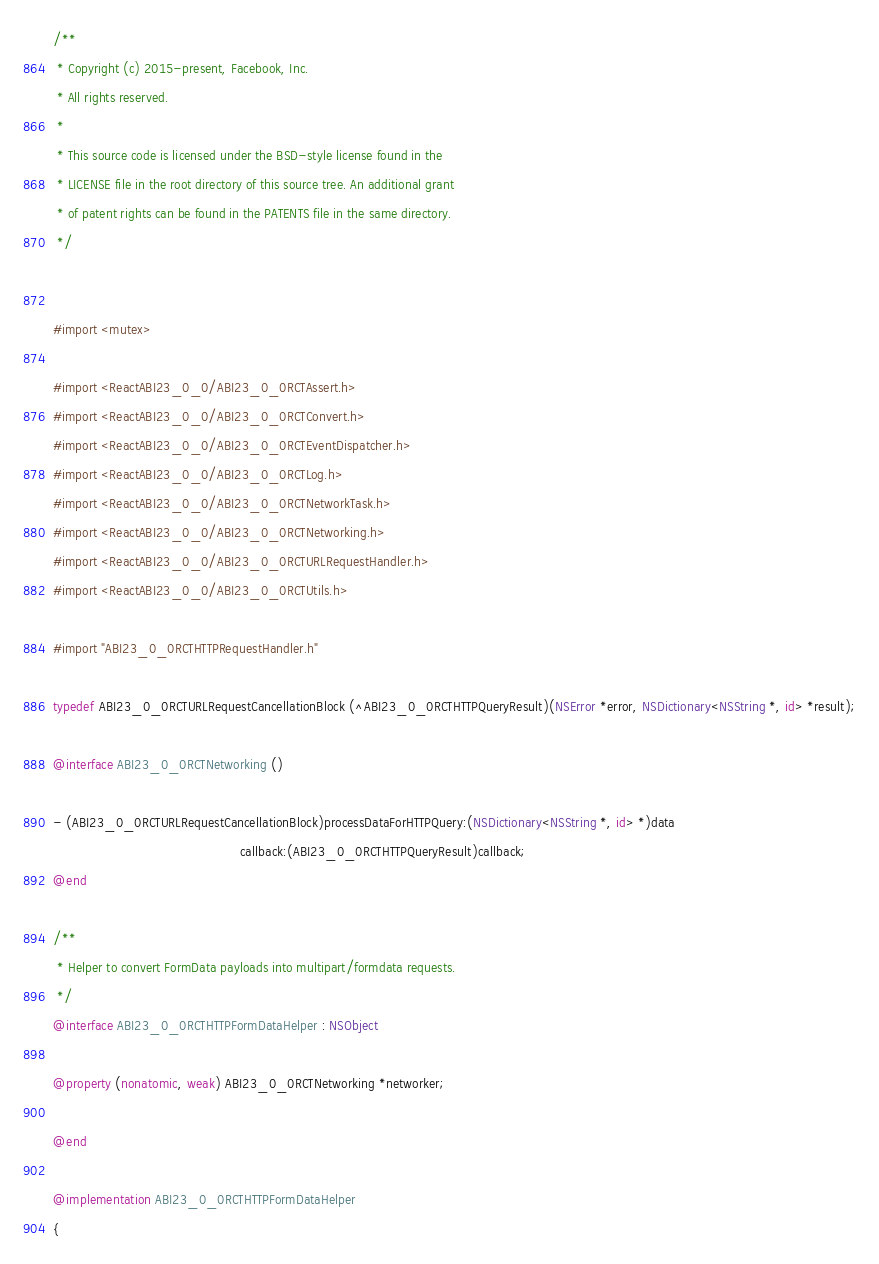Convert code to text. <code><loc_0><loc_0><loc_500><loc_500><_ObjectiveC_>/**
 * Copyright (c) 2015-present, Facebook, Inc.
 * All rights reserved.
 *
 * This source code is licensed under the BSD-style license found in the
 * LICENSE file in the root directory of this source tree. An additional grant
 * of patent rights can be found in the PATENTS file in the same directory.
 */


#import <mutex>

#import <ReactABI23_0_0/ABI23_0_0RCTAssert.h>
#import <ReactABI23_0_0/ABI23_0_0RCTConvert.h>
#import <ReactABI23_0_0/ABI23_0_0RCTEventDispatcher.h>
#import <ReactABI23_0_0/ABI23_0_0RCTLog.h>
#import <ReactABI23_0_0/ABI23_0_0RCTNetworkTask.h>
#import <ReactABI23_0_0/ABI23_0_0RCTNetworking.h>
#import <ReactABI23_0_0/ABI23_0_0RCTURLRequestHandler.h>
#import <ReactABI23_0_0/ABI23_0_0RCTUtils.h>

#import "ABI23_0_0RCTHTTPRequestHandler.h"

typedef ABI23_0_0RCTURLRequestCancellationBlock (^ABI23_0_0RCTHTTPQueryResult)(NSError *error, NSDictionary<NSString *, id> *result);

@interface ABI23_0_0RCTNetworking ()

- (ABI23_0_0RCTURLRequestCancellationBlock)processDataForHTTPQuery:(NSDictionary<NSString *, id> *)data
                                                 callback:(ABI23_0_0RCTHTTPQueryResult)callback;
@end

/**
 * Helper to convert FormData payloads into multipart/formdata requests.
 */
@interface ABI23_0_0RCTHTTPFormDataHelper : NSObject

@property (nonatomic, weak) ABI23_0_0RCTNetworking *networker;

@end

@implementation ABI23_0_0RCTHTTPFormDataHelper
{</code> 